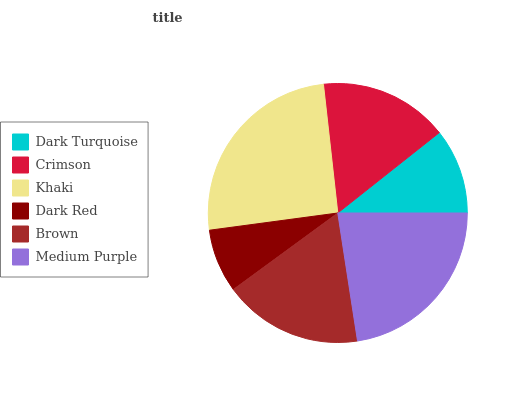Is Dark Red the minimum?
Answer yes or no. Yes. Is Khaki the maximum?
Answer yes or no. Yes. Is Crimson the minimum?
Answer yes or no. No. Is Crimson the maximum?
Answer yes or no. No. Is Crimson greater than Dark Turquoise?
Answer yes or no. Yes. Is Dark Turquoise less than Crimson?
Answer yes or no. Yes. Is Dark Turquoise greater than Crimson?
Answer yes or no. No. Is Crimson less than Dark Turquoise?
Answer yes or no. No. Is Brown the high median?
Answer yes or no. Yes. Is Crimson the low median?
Answer yes or no. Yes. Is Dark Red the high median?
Answer yes or no. No. Is Medium Purple the low median?
Answer yes or no. No. 